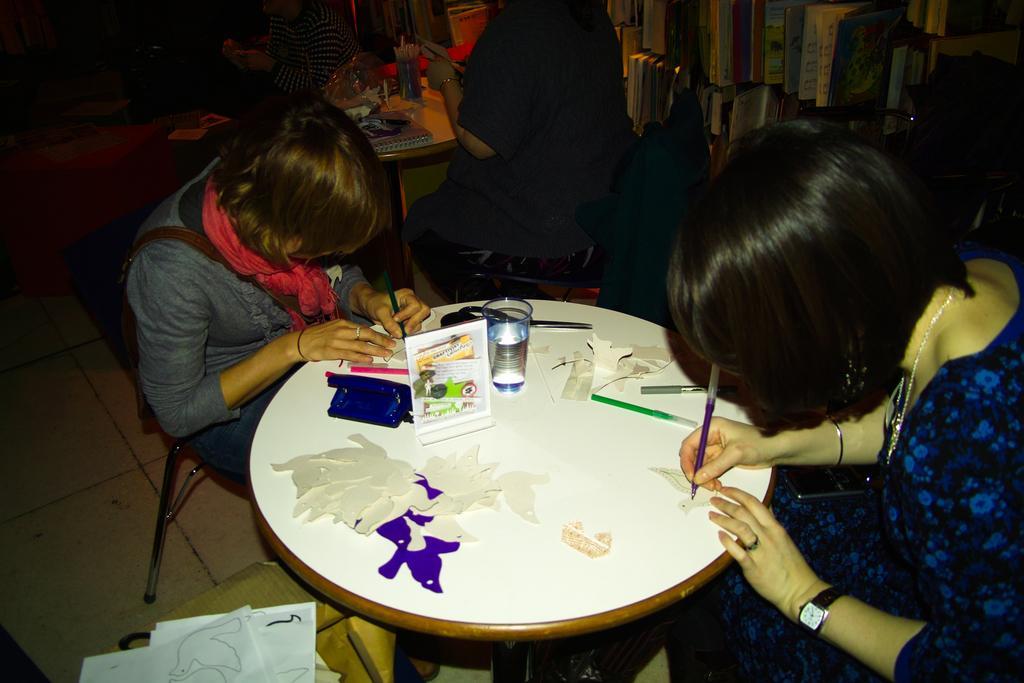In one or two sentences, can you explain what this image depicts? As we can see in the image there are few people sitting on chairs. On the floor there are papers. On table there is a glass, scissors, pens, colors and a poster. 